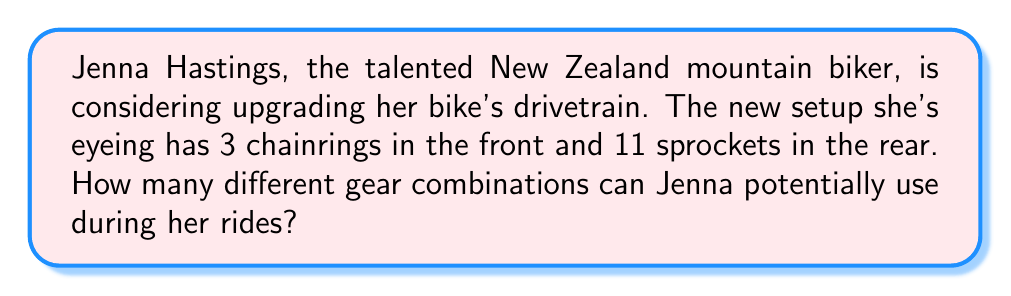What is the answer to this math problem? To solve this problem, we need to use the fundamental counting principle. This principle states that if we have two independent events, where one event can occur in $m$ ways and the other in $n$ ways, then the two events can occur together in $m \times n$ ways.

In this case, we have:
1. Front chainrings: 3 options
2. Rear sprockets: 11 options

Each front chainring can be paired with any of the rear sprockets. Therefore, we multiply these numbers:

$$ \text{Total combinations} = \text{Number of chainrings} \times \text{Number of sprockets} $$
$$ \text{Total combinations} = 3 \times 11 = 33 $$

It's worth noting that while there are 33 possible combinations, some may be impractical due to the chain angle (cross-chaining). However, the question asks for all possible combinations, so we include all of them in our count.
Answer: $$ 33 \text{ gear combinations} $$ 